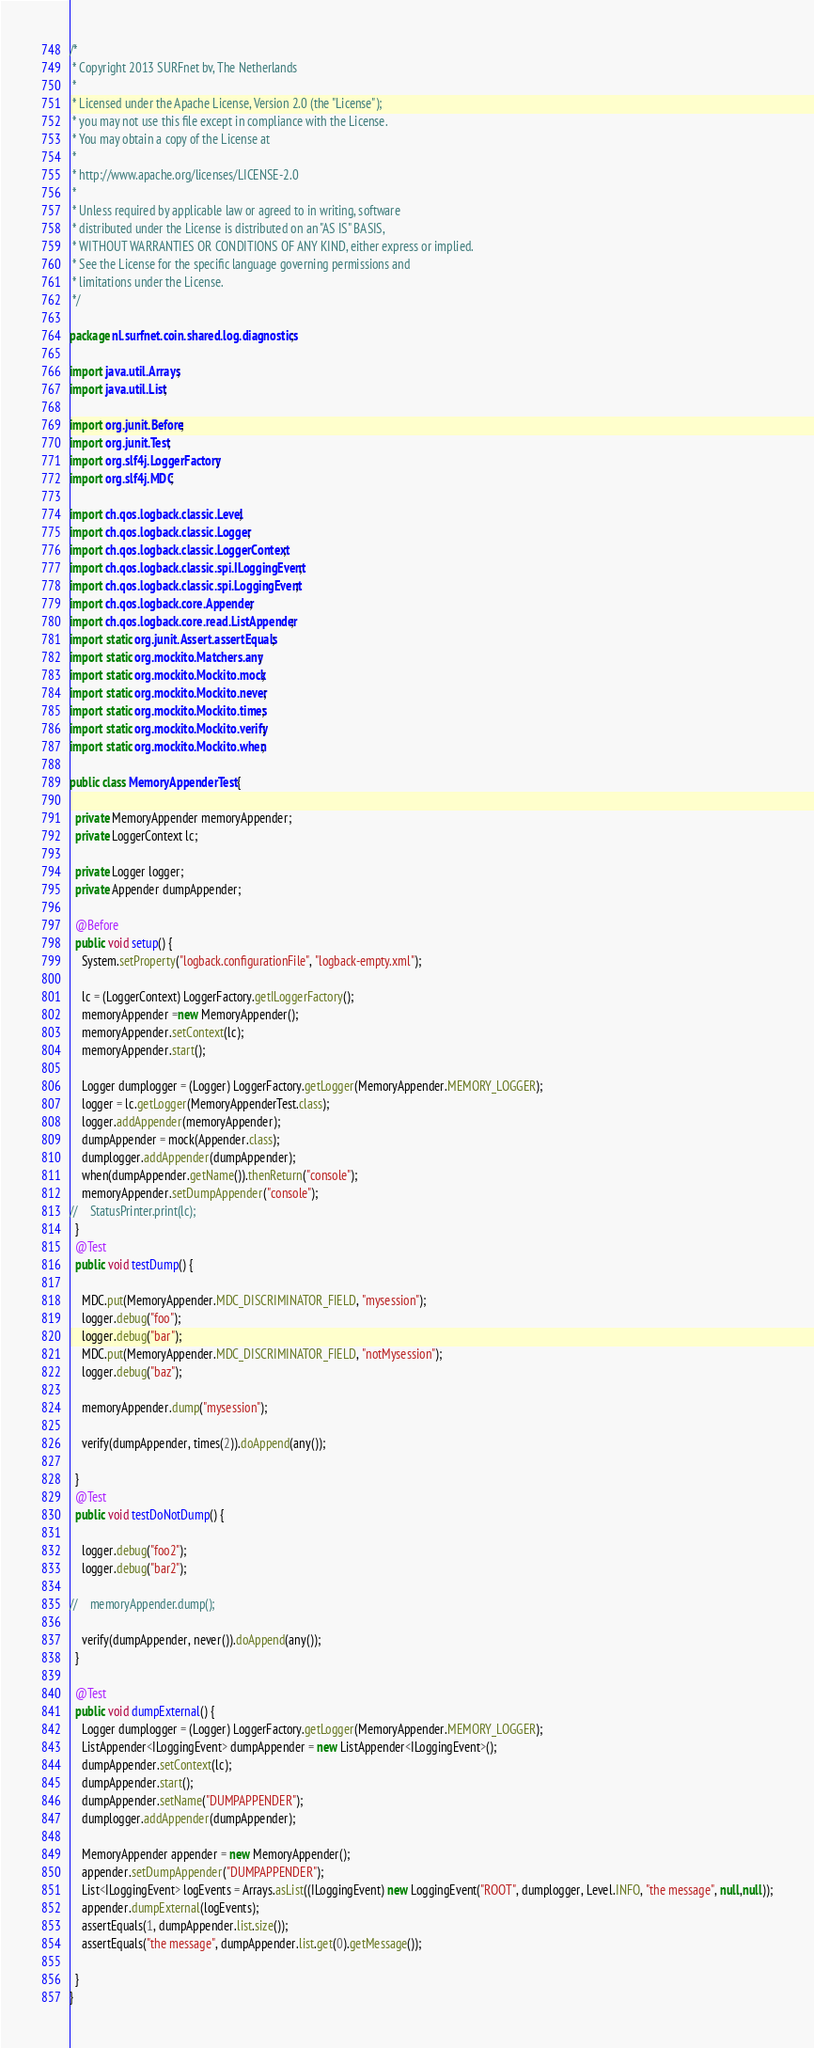Convert code to text. <code><loc_0><loc_0><loc_500><loc_500><_Java_>/*
 * Copyright 2013 SURFnet bv, The Netherlands
 *
 * Licensed under the Apache License, Version 2.0 (the "License");
 * you may not use this file except in compliance with the License.
 * You may obtain a copy of the License at
 *
 * http://www.apache.org/licenses/LICENSE-2.0
 *
 * Unless required by applicable law or agreed to in writing, software
 * distributed under the License is distributed on an "AS IS" BASIS,
 * WITHOUT WARRANTIES OR CONDITIONS OF ANY KIND, either express or implied.
 * See the License for the specific language governing permissions and
 * limitations under the License.
 */

package nl.surfnet.coin.shared.log.diagnostics;

import java.util.Arrays;
import java.util.List;

import org.junit.Before;
import org.junit.Test;
import org.slf4j.LoggerFactory;
import org.slf4j.MDC;

import ch.qos.logback.classic.Level;
import ch.qos.logback.classic.Logger;
import ch.qos.logback.classic.LoggerContext;
import ch.qos.logback.classic.spi.ILoggingEvent;
import ch.qos.logback.classic.spi.LoggingEvent;
import ch.qos.logback.core.Appender;
import ch.qos.logback.core.read.ListAppender;
import static org.junit.Assert.assertEquals;
import static org.mockito.Matchers.any;
import static org.mockito.Mockito.mock;
import static org.mockito.Mockito.never;
import static org.mockito.Mockito.times;
import static org.mockito.Mockito.verify;
import static org.mockito.Mockito.when;

public class MemoryAppenderTest {

  private MemoryAppender memoryAppender;
  private LoggerContext lc;

  private Logger logger;
  private Appender dumpAppender;

  @Before
  public void setup() {
    System.setProperty("logback.configurationFile", "logback-empty.xml");

    lc = (LoggerContext) LoggerFactory.getILoggerFactory();
    memoryAppender =new MemoryAppender();
    memoryAppender.setContext(lc);
    memoryAppender.start();

    Logger dumplogger = (Logger) LoggerFactory.getLogger(MemoryAppender.MEMORY_LOGGER);
    logger = lc.getLogger(MemoryAppenderTest.class);
    logger.addAppender(memoryAppender);
    dumpAppender = mock(Appender.class);
    dumplogger.addAppender(dumpAppender);
    when(dumpAppender.getName()).thenReturn("console");
    memoryAppender.setDumpAppender("console");
//    StatusPrinter.print(lc);
  }
  @Test
  public void testDump() {

    MDC.put(MemoryAppender.MDC_DISCRIMINATOR_FIELD, "mysession");
    logger.debug("foo");
    logger.debug("bar");
    MDC.put(MemoryAppender.MDC_DISCRIMINATOR_FIELD, "notMysession");
    logger.debug("baz");

    memoryAppender.dump("mysession");

    verify(dumpAppender, times(2)).doAppend(any());

  }
  @Test
  public void testDoNotDump() {

    logger.debug("foo2");
    logger.debug("bar2");

//    memoryAppender.dump();

    verify(dumpAppender, never()).doAppend(any());
  }

  @Test
  public void dumpExternal() {
    Logger dumplogger = (Logger) LoggerFactory.getLogger(MemoryAppender.MEMORY_LOGGER);
    ListAppender<ILoggingEvent> dumpAppender = new ListAppender<ILoggingEvent>();
    dumpAppender.setContext(lc);
    dumpAppender.start();
    dumpAppender.setName("DUMPAPPENDER");
    dumplogger.addAppender(dumpAppender);

    MemoryAppender appender = new MemoryAppender();
    appender.setDumpAppender("DUMPAPPENDER");
    List<ILoggingEvent> logEvents = Arrays.asList((ILoggingEvent) new LoggingEvent("ROOT", dumplogger, Level.INFO, "the message", null,null));
    appender.dumpExternal(logEvents);
    assertEquals(1, dumpAppender.list.size());
    assertEquals("the message", dumpAppender.list.get(0).getMessage());

  }
}
</code> 